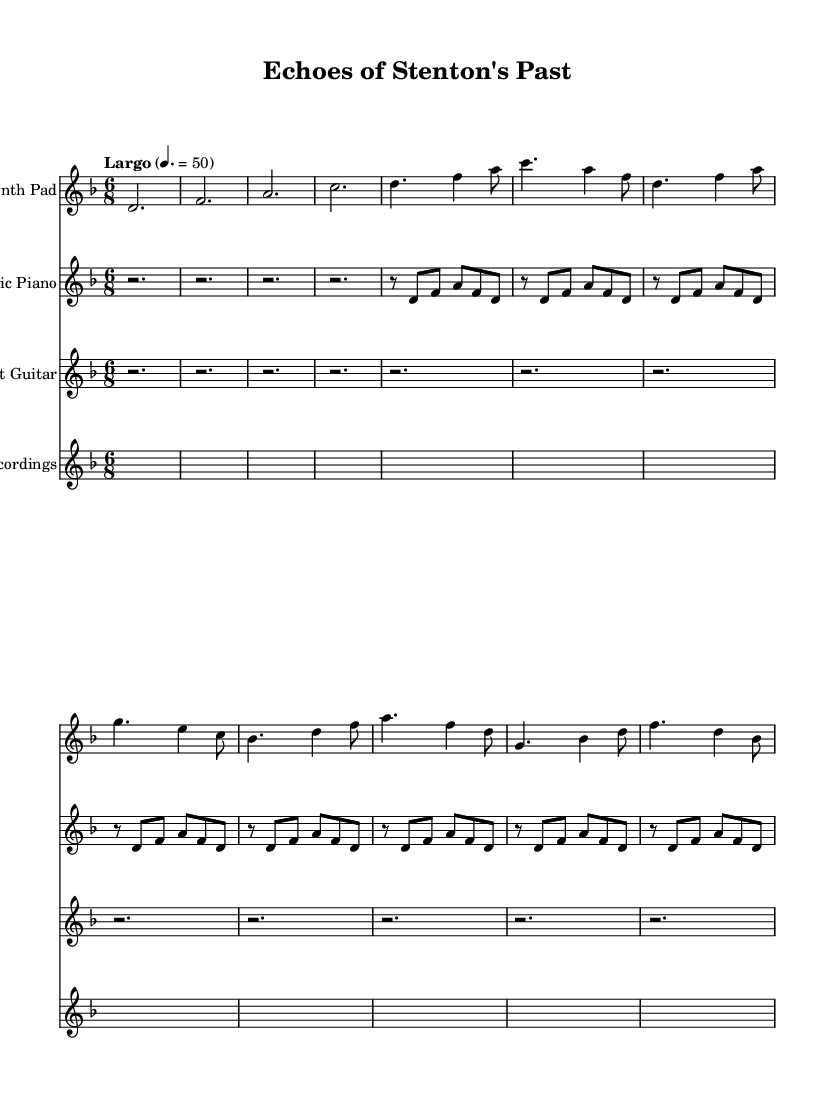What is the key signature of this music? The key signature is D minor, which has one flat (B flat). This can be identified from the key signature notation at the beginning of the score.
Answer: D minor What is the time signature of this music? The time signature is 6/8, which allows for a compound meter typically felt in two beats with three eighth notes each. This is indicated at the start of the score.
Answer: 6/8 What is the tempo marking for this piece? The tempo marking is Largo, indicated at the beginning of the score, which suggests a slow pace. The metronome marking shows 50 beats per minute.
Answer: Largo How many measures are there in the synth pad part? The synth pad part consists of 12 measures, as counted from the beginning of the part to the end.
Answer: 12 Which instrument has sustained rests in its part? The ambient guitar section contains sustained rests, as represented by the repeated rests without melodic notes. This draws attention to its atmospheric role.
Answer: Ambient Guitar What elements are included in the field recordings staff? The field recordings staff is represented as silence throughout the duration, indicated by the whole rests shown. This implies that it captures ambient sound without melodic contribution.
Answer: Silence What is the rhythmic pattern in the electric piano part? The rhythm in the electric piano part alternates between rests and a sequence of eight notes, creating a repetitive and spacious texture, which contributes to the overall ambient sound.
Answer: Repetitive 